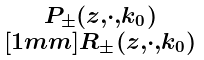Convert formula to latex. <formula><loc_0><loc_0><loc_500><loc_500>\begin{smallmatrix} P _ { \pm } ( z , \cdot , k _ { 0 } ) \\ [ 1 m m ] R _ { \pm } ( z , \cdot , k _ { 0 } ) \end{smallmatrix}</formula> 